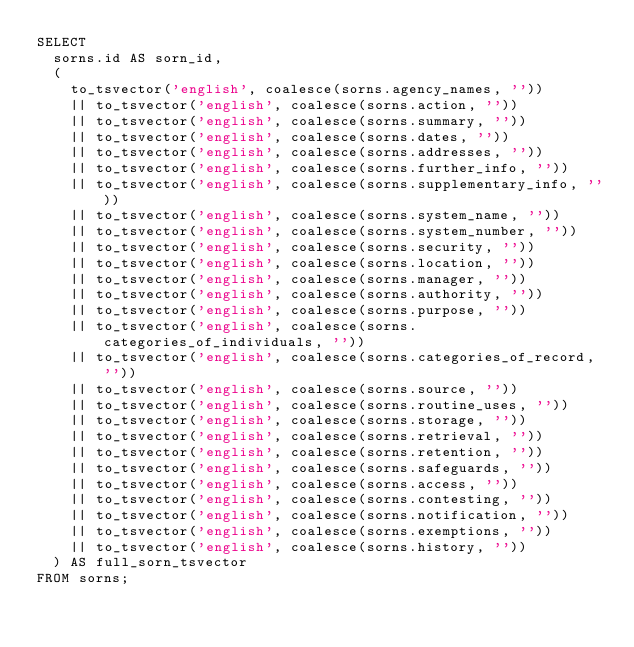Convert code to text. <code><loc_0><loc_0><loc_500><loc_500><_SQL_>SELECT
  sorns.id AS sorn_id,
  (
    to_tsvector('english', coalesce(sorns.agency_names, ''))
    || to_tsvector('english', coalesce(sorns.action, ''))
    || to_tsvector('english', coalesce(sorns.summary, ''))
    || to_tsvector('english', coalesce(sorns.dates, ''))
    || to_tsvector('english', coalesce(sorns.addresses, ''))
    || to_tsvector('english', coalesce(sorns.further_info, ''))
    || to_tsvector('english', coalesce(sorns.supplementary_info, ''))
    || to_tsvector('english', coalesce(sorns.system_name, ''))
    || to_tsvector('english', coalesce(sorns.system_number, ''))
    || to_tsvector('english', coalesce(sorns.security, ''))
    || to_tsvector('english', coalesce(sorns.location, ''))
    || to_tsvector('english', coalesce(sorns.manager, ''))
    || to_tsvector('english', coalesce(sorns.authority, ''))
    || to_tsvector('english', coalesce(sorns.purpose, ''))
    || to_tsvector('english', coalesce(sorns.categories_of_individuals, ''))
    || to_tsvector('english', coalesce(sorns.categories_of_record, ''))
    || to_tsvector('english', coalesce(sorns.source, ''))
    || to_tsvector('english', coalesce(sorns.routine_uses, ''))
    || to_tsvector('english', coalesce(sorns.storage, ''))
    || to_tsvector('english', coalesce(sorns.retrieval, ''))
    || to_tsvector('english', coalesce(sorns.retention, ''))
    || to_tsvector('english', coalesce(sorns.safeguards, ''))
    || to_tsvector('english', coalesce(sorns.access, ''))
    || to_tsvector('english', coalesce(sorns.contesting, ''))
    || to_tsvector('english', coalesce(sorns.notification, ''))
    || to_tsvector('english', coalesce(sorns.exemptions, ''))
    || to_tsvector('english', coalesce(sorns.history, ''))
  ) AS full_sorn_tsvector
FROM sorns;</code> 